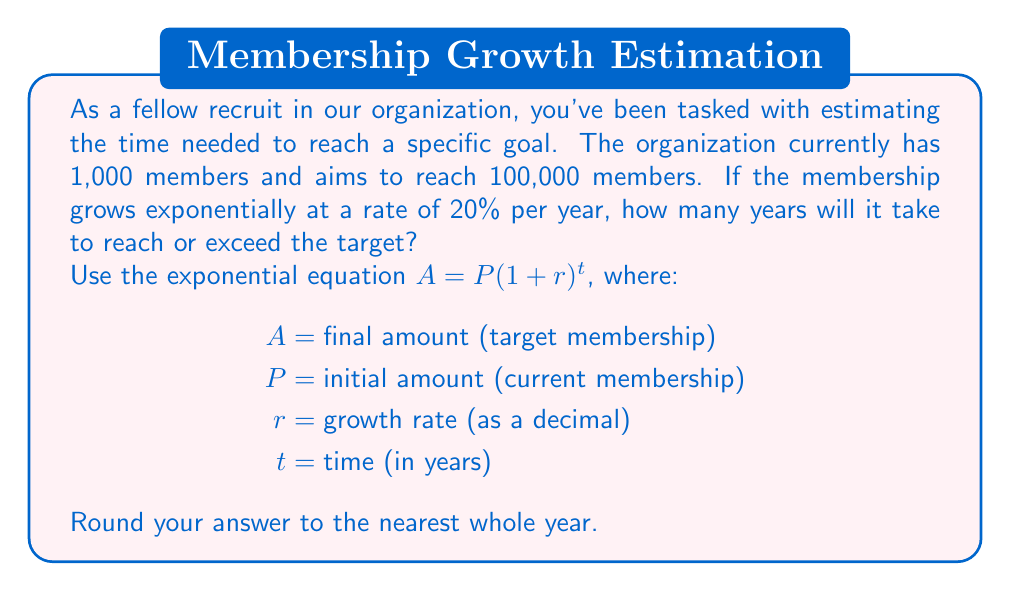Show me your answer to this math problem. Let's approach this step-by-step:

1) We're given:
   $A = 100,000$ (target membership)
   $P = 1,000$ (current membership)
   $r = 0.20$ (20% growth rate as a decimal)
   
2) We need to solve for $t$ in the equation:
   $$100,000 = 1,000(1 + 0.20)^t$$

3) Simplify the right side:
   $$100,000 = 1,000(1.20)^t$$

4) Divide both sides by 1,000:
   $$100 = (1.20)^t$$

5) Take the natural logarithm of both sides:
   $$\ln(100) = \ln((1.20)^t)$$

6) Use the logarithm property $\ln(a^b) = b\ln(a)$:
   $$\ln(100) = t\ln(1.20)$$

7) Solve for $t$:
   $$t = \frac{\ln(100)}{\ln(1.20)}$$

8) Calculate:
   $$t \approx \frac{4.6052}{0.1823} \approx 25.2615$$

9) Rounding to the nearest whole year:
   $t = 25$ years
Answer: It will take approximately 25 years to reach or exceed the target of 100,000 members. 